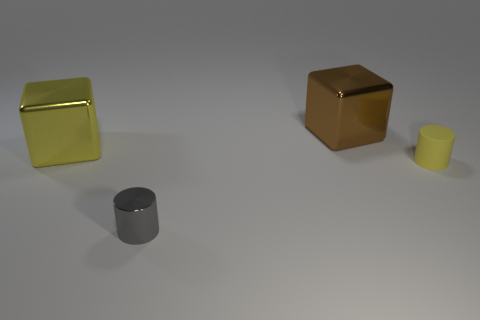Add 4 gray objects. How many objects exist? 8 Add 4 big brown metallic cubes. How many big brown metallic cubes are left? 5 Add 4 brown blocks. How many brown blocks exist? 5 Subtract 0 blue blocks. How many objects are left? 4 Subtract all tiny gray objects. Subtract all small gray shiny cylinders. How many objects are left? 2 